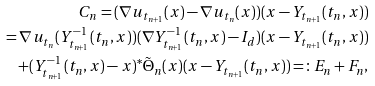<formula> <loc_0><loc_0><loc_500><loc_500>C _ { n } = ( \nabla u _ { t _ { n + 1 } } ( x ) - \nabla u _ { t _ { n } } ( x ) ) ( x - Y _ { t _ { n + 1 } } ( t _ { n } , x ) ) \\ = \nabla u _ { t _ { n } } ( Y _ { t _ { n + 1 } } ^ { - 1 } ( t _ { n } , x ) ) ( \nabla Y _ { t _ { n + 1 } } ^ { - 1 } ( t _ { n } , x ) - I _ { d } ) ( x - Y _ { t _ { n + 1 } } ( t _ { n } , x ) ) \\ + ( Y _ { t _ { n + 1 } } ^ { - 1 } ( t _ { n } , x ) - x ) ^ { * } \tilde { \Theta } _ { n } ( x ) ( x - Y _ { t _ { n + 1 } } ( t _ { n } , x ) ) = \colon E _ { n } + F _ { n } ,</formula> 